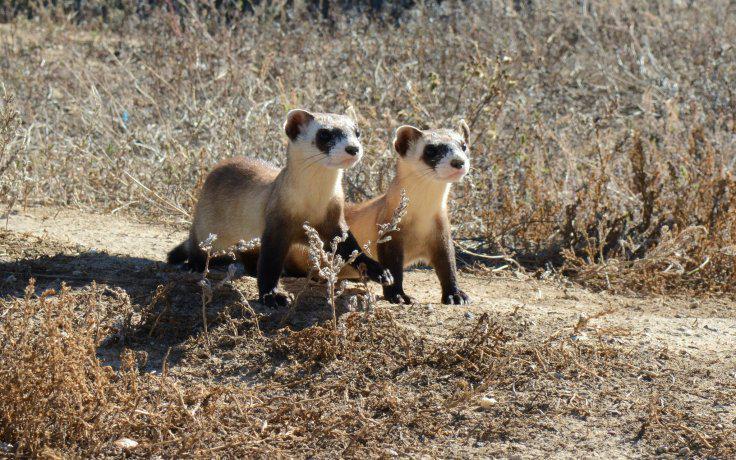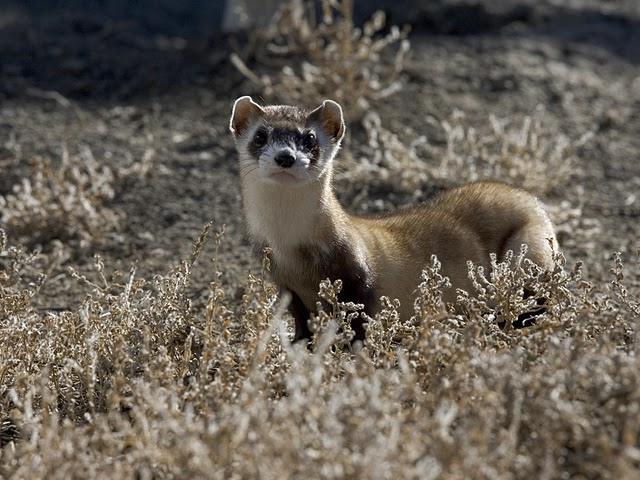The first image is the image on the left, the second image is the image on the right. Given the left and right images, does the statement "The combined images include two ferrets in very similar poses, with heads turned the same direction, and all ferrets have raised heads." hold true? Answer yes or no. Yes. The first image is the image on the left, the second image is the image on the right. Given the left and right images, does the statement "In one of the images there are 2 animals." hold true? Answer yes or no. Yes. 